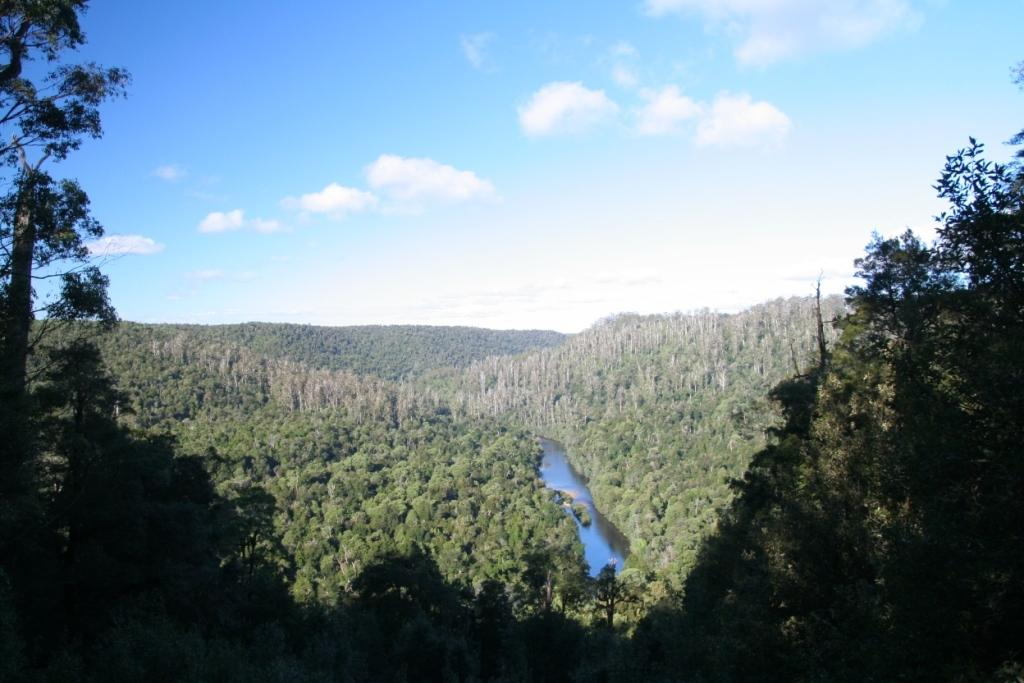What can be seen in the sky in the image? The sky with clouds is visible in the image. What type of vegetation is present in the image? There are trees in the image. What natural feature is present in the image? There is a river in the image. What type of competition is taking place near the river in the image? There is no competition present in the image; it only features the sky, trees, and a river. Can you see any crayons being used to draw on the trees in the image? There are no crayons or drawing activity present in the image. 